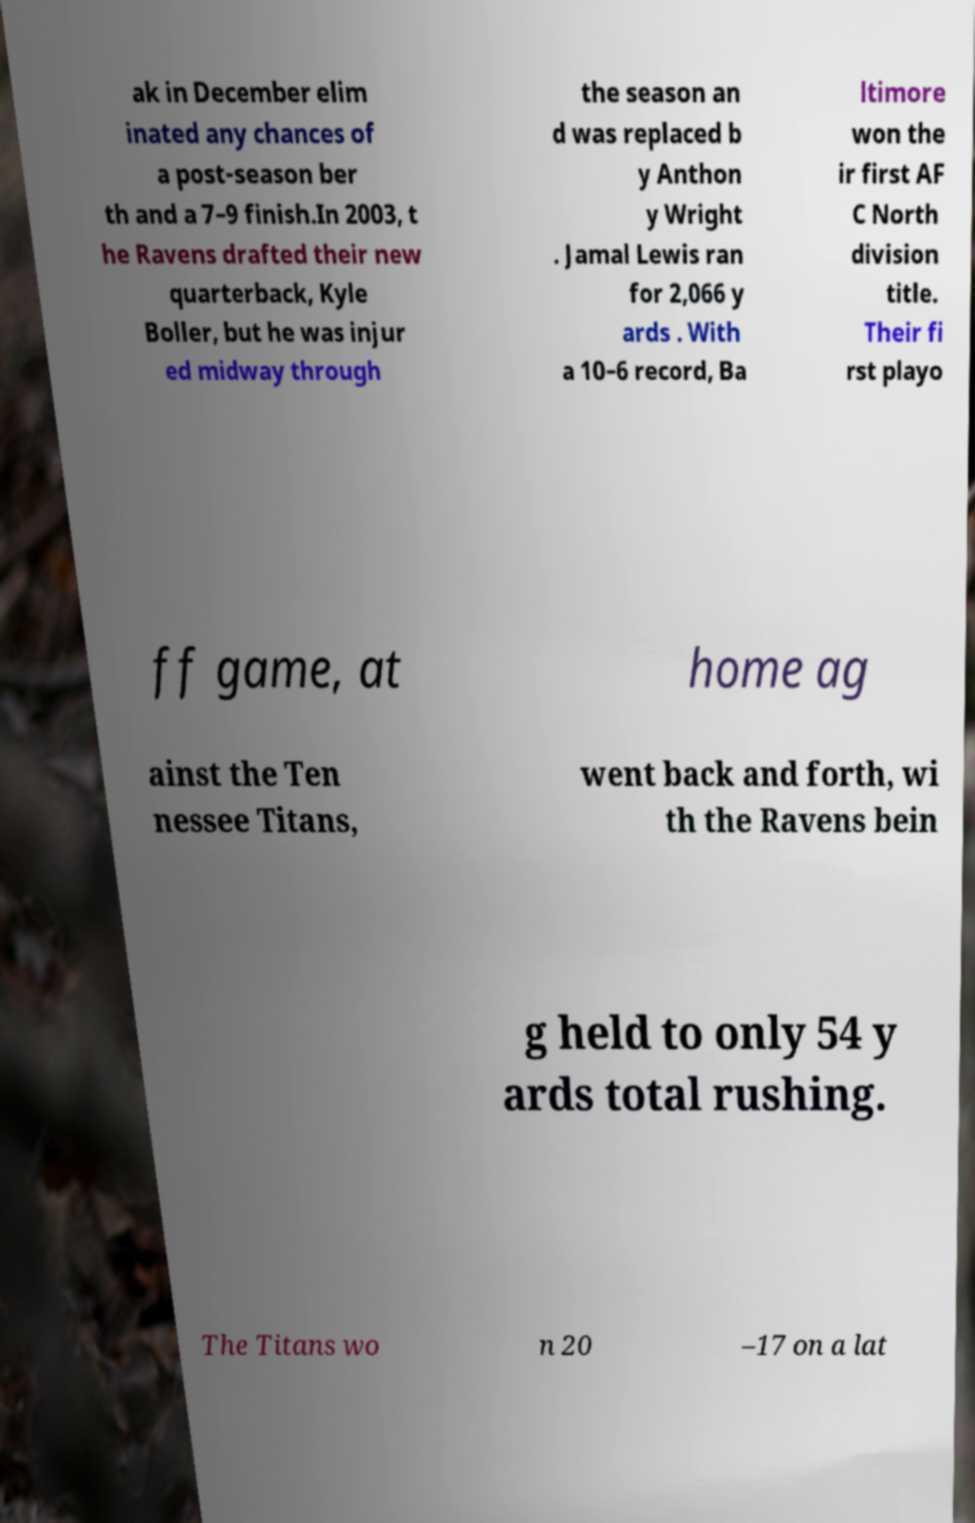Could you extract and type out the text from this image? ak in December elim inated any chances of a post-season ber th and a 7–9 finish.In 2003, t he Ravens drafted their new quarterback, Kyle Boller, but he was injur ed midway through the season an d was replaced b y Anthon y Wright . Jamal Lewis ran for 2,066 y ards . With a 10–6 record, Ba ltimore won the ir first AF C North division title. Their fi rst playo ff game, at home ag ainst the Ten nessee Titans, went back and forth, wi th the Ravens bein g held to only 54 y ards total rushing. The Titans wo n 20 –17 on a lat 